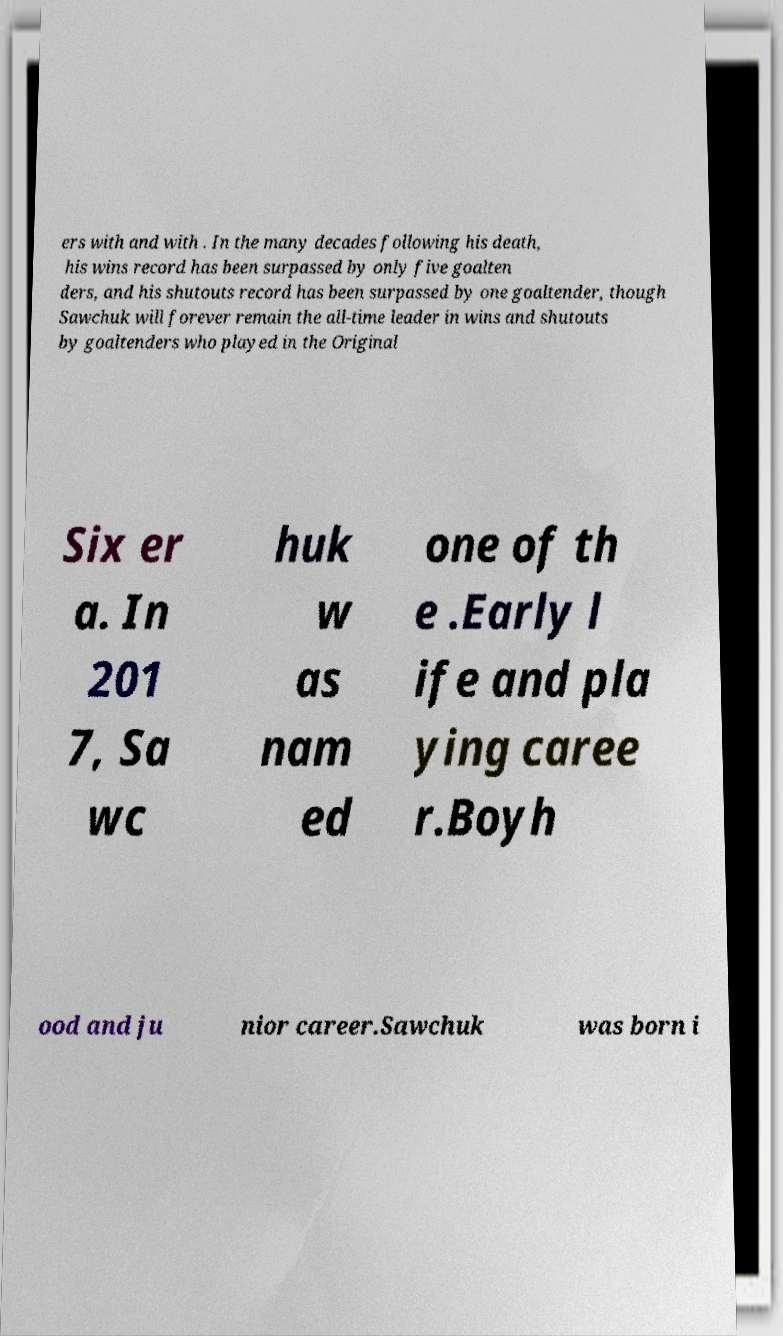I need the written content from this picture converted into text. Can you do that? ers with and with . In the many decades following his death, his wins record has been surpassed by only five goalten ders, and his shutouts record has been surpassed by one goaltender, though Sawchuk will forever remain the all-time leader in wins and shutouts by goaltenders who played in the Original Six er a. In 201 7, Sa wc huk w as nam ed one of th e .Early l ife and pla ying caree r.Boyh ood and ju nior career.Sawchuk was born i 